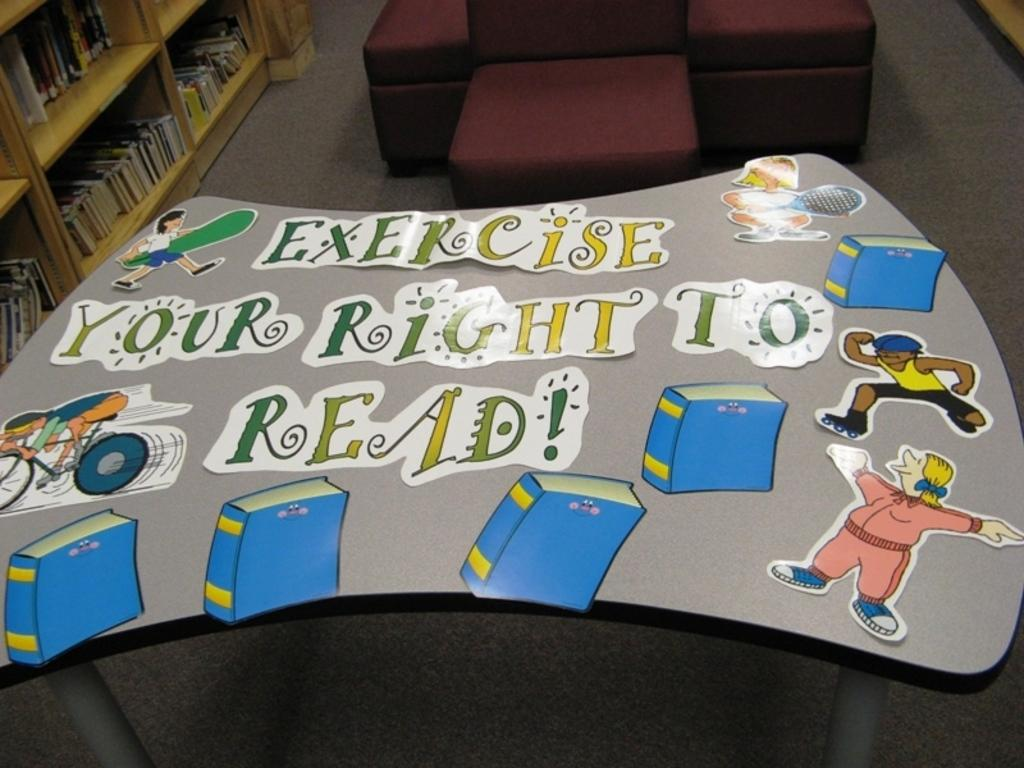<image>
Describe the image concisely. A kids table in a library is decorated with the slogan exercise your right to read. 